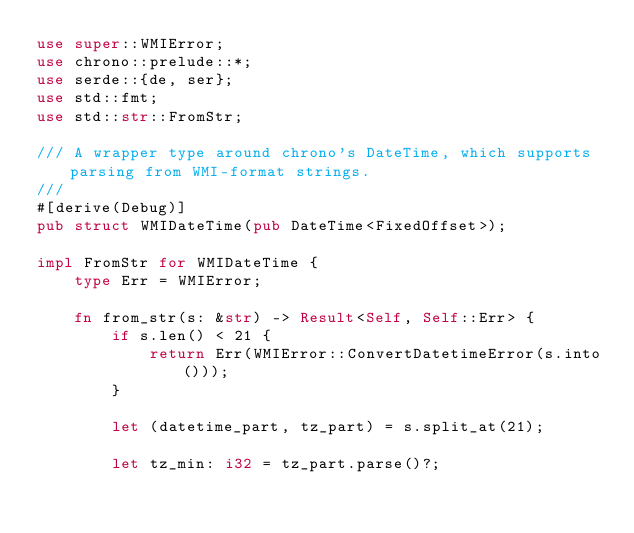<code> <loc_0><loc_0><loc_500><loc_500><_Rust_>use super::WMIError;
use chrono::prelude::*;
use serde::{de, ser};
use std::fmt;
use std::str::FromStr;

/// A wrapper type around chrono's DateTime, which supports parsing from WMI-format strings.
///
#[derive(Debug)]
pub struct WMIDateTime(pub DateTime<FixedOffset>);

impl FromStr for WMIDateTime {
    type Err = WMIError;

    fn from_str(s: &str) -> Result<Self, Self::Err> {
        if s.len() < 21 {
            return Err(WMIError::ConvertDatetimeError(s.into()));
        }

        let (datetime_part, tz_part) = s.split_at(21);

        let tz_min: i32 = tz_part.parse()?;
</code> 